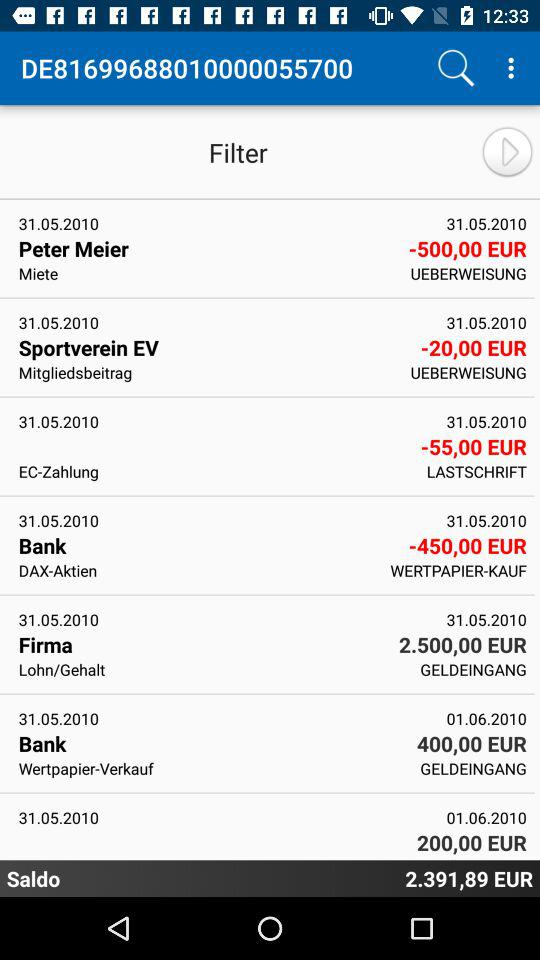What currency is shown? The shown currency is EUR. 